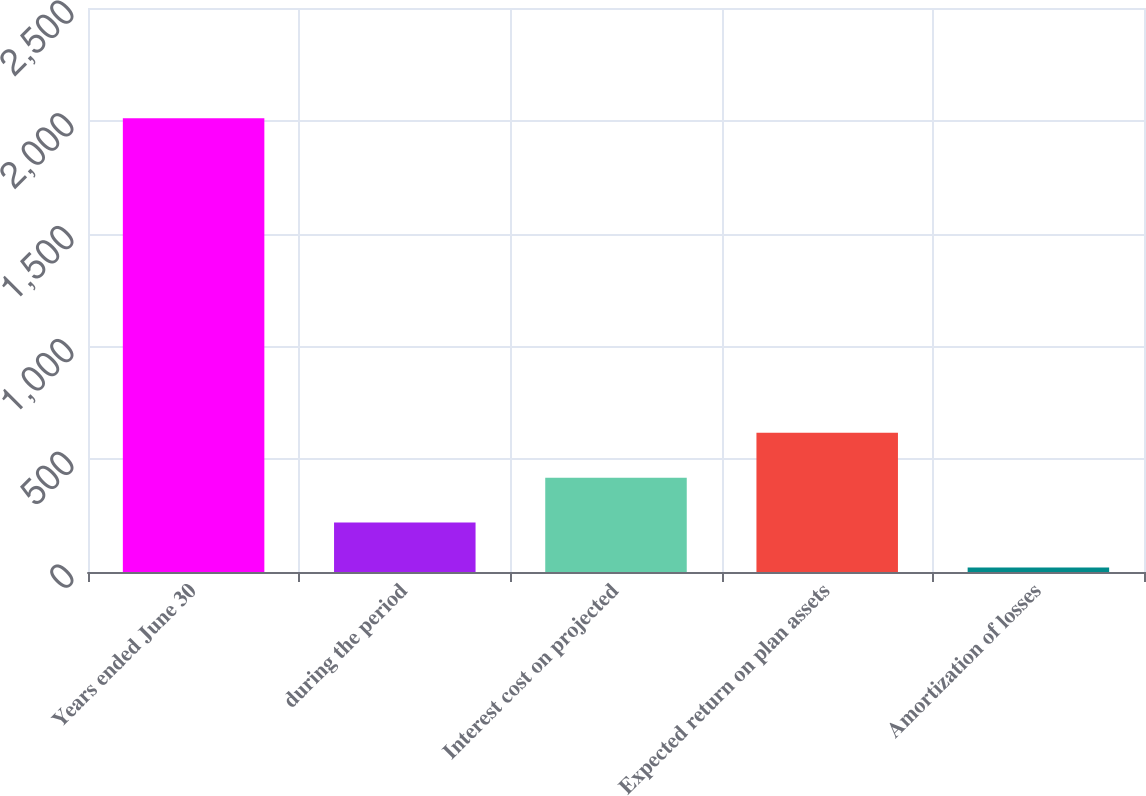Convert chart to OTSL. <chart><loc_0><loc_0><loc_500><loc_500><bar_chart><fcel>Years ended June 30<fcel>during the period<fcel>Interest cost on projected<fcel>Expected return on plan assets<fcel>Amortization of losses<nl><fcel>2011<fcel>219.19<fcel>418.28<fcel>617.37<fcel>20.1<nl></chart> 